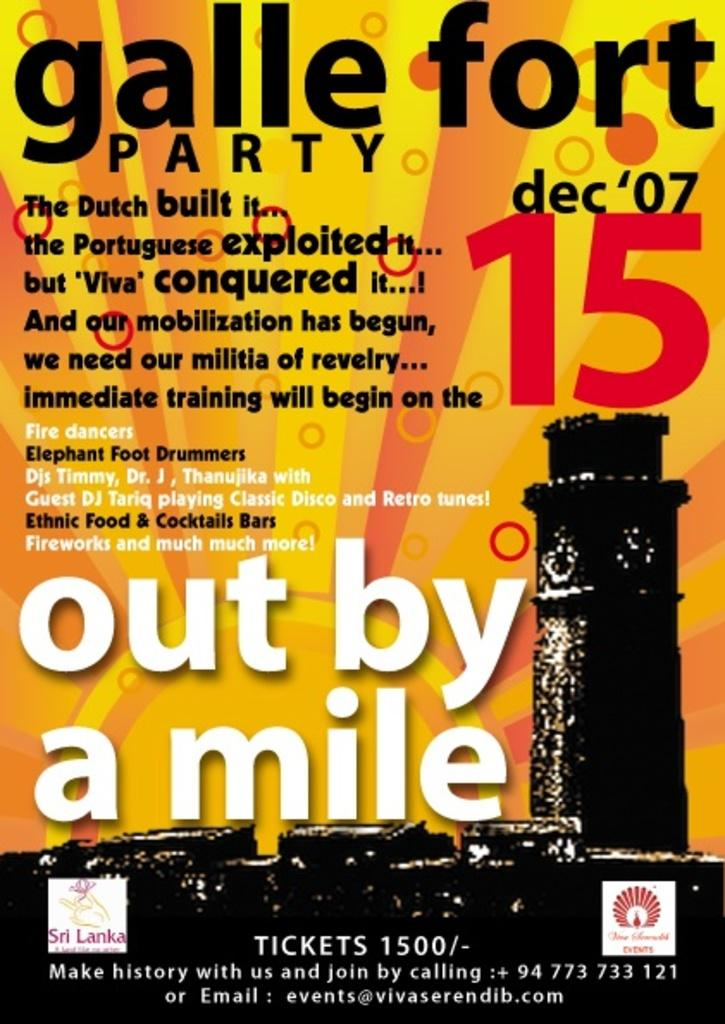Provide a one-sentence caption for the provided image. yellow and orange poster for galle forte party on dec 7, 2015. 